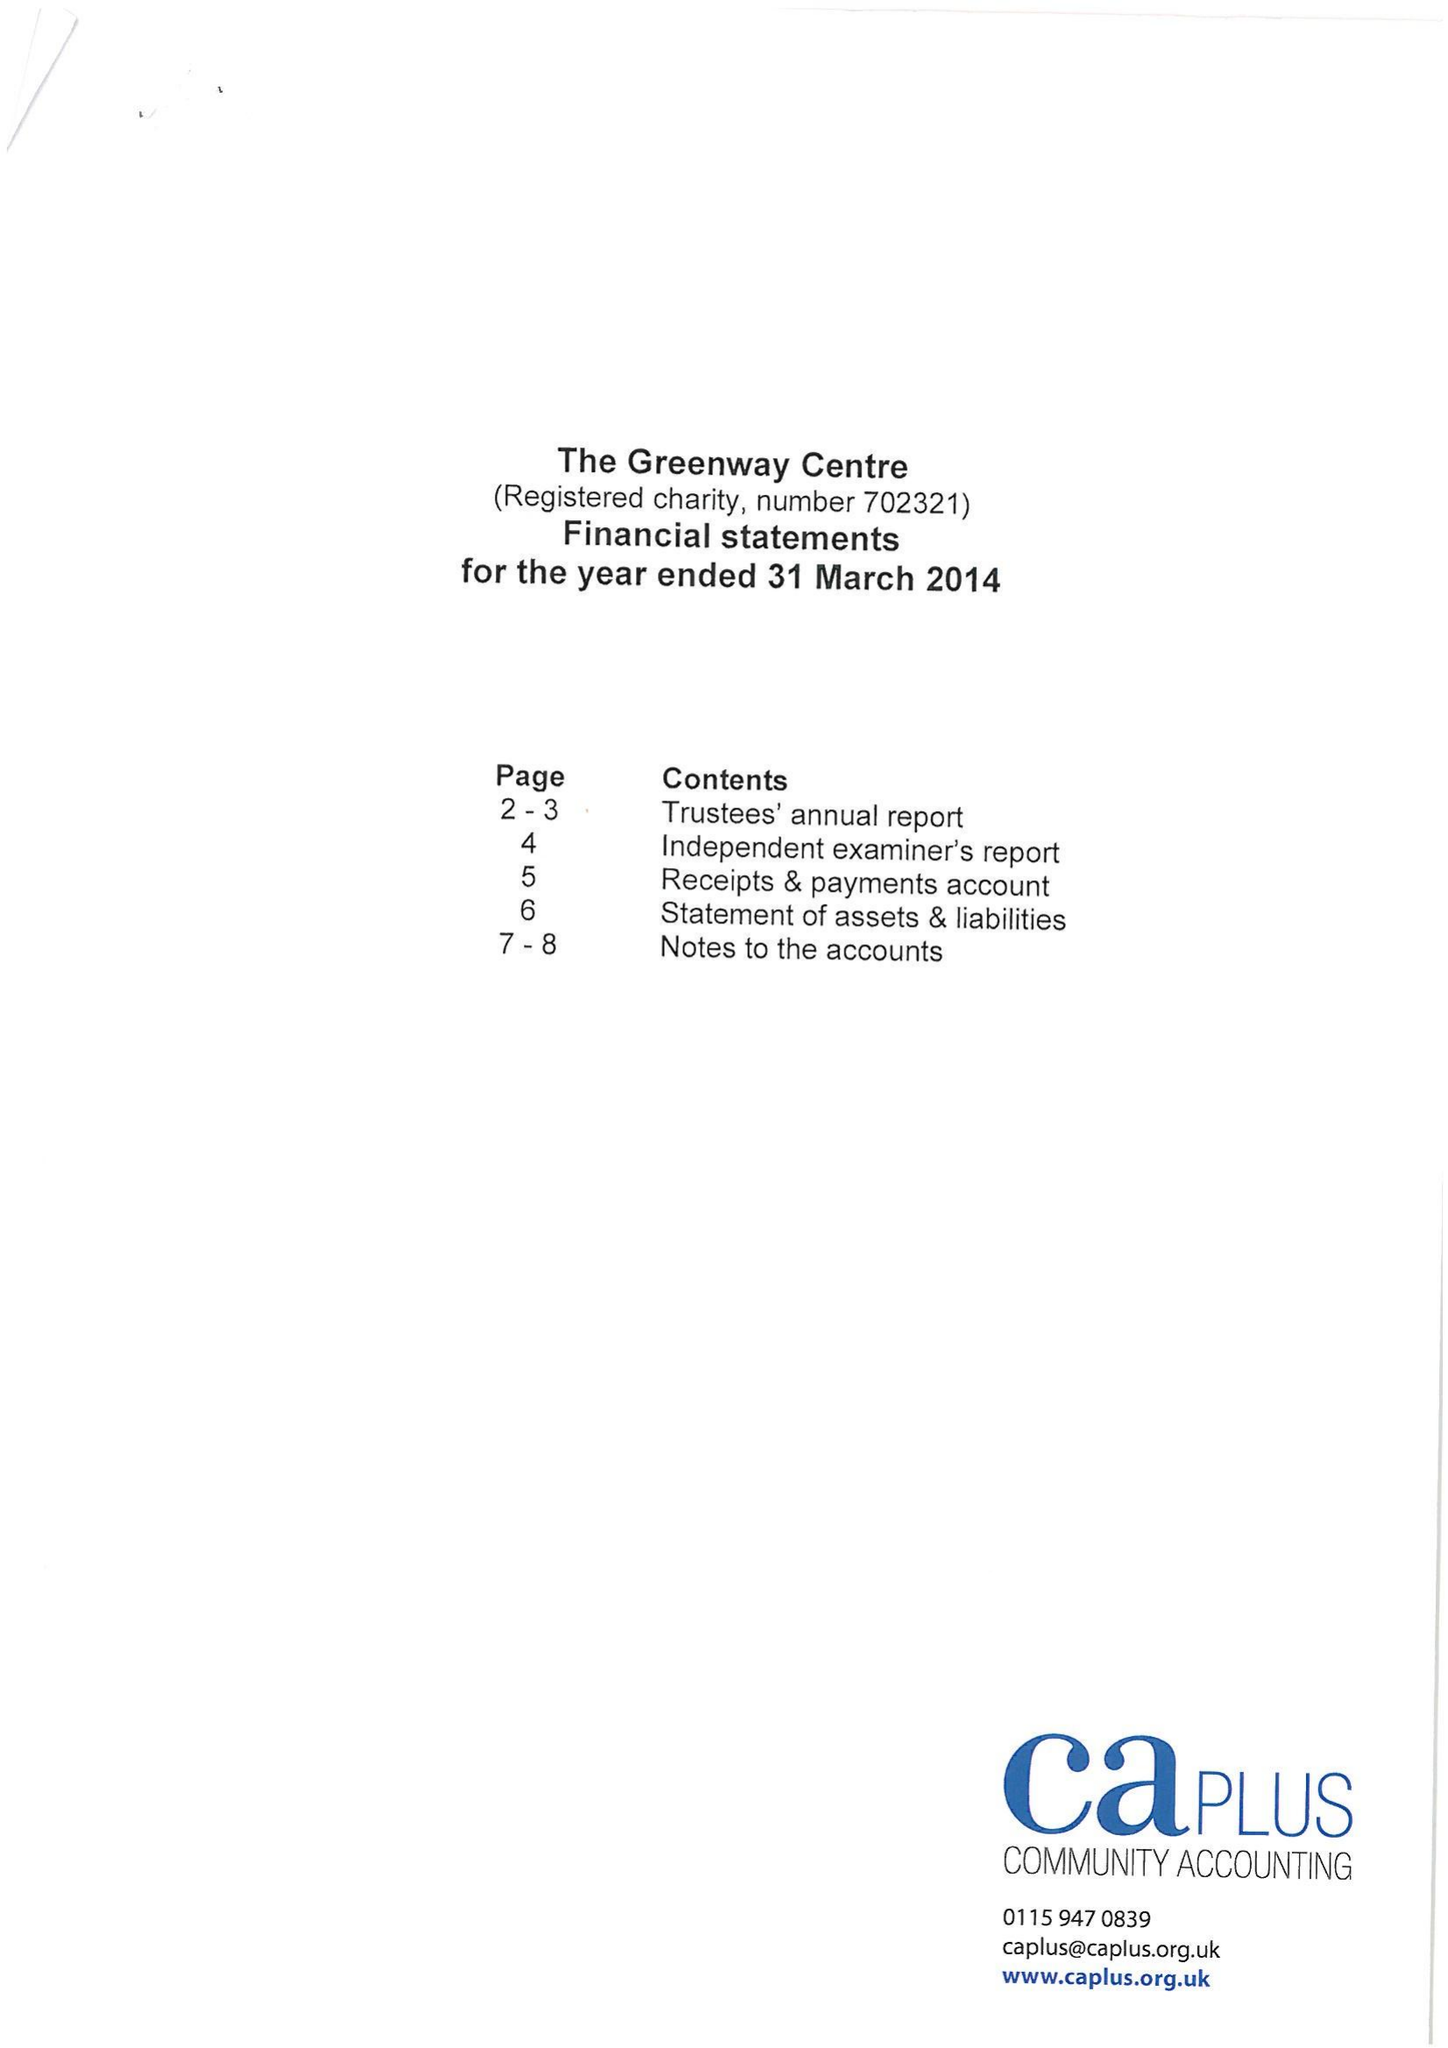What is the value for the charity_number?
Answer the question using a single word or phrase. 702321 